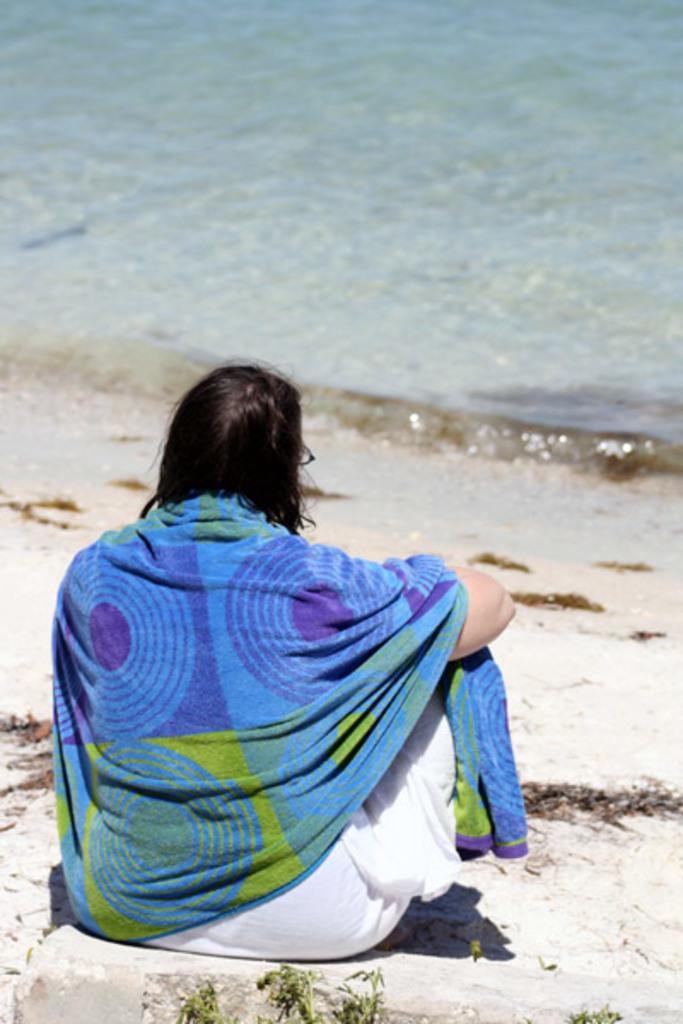Could you give a brief overview of what you see in this image? The woman in the middle of the picture wearing white dress and blue towel is sitting. Beside her, we see sand. In front of her, we see water and this water might be in the sea. This picture might be clicked at the seashore. 